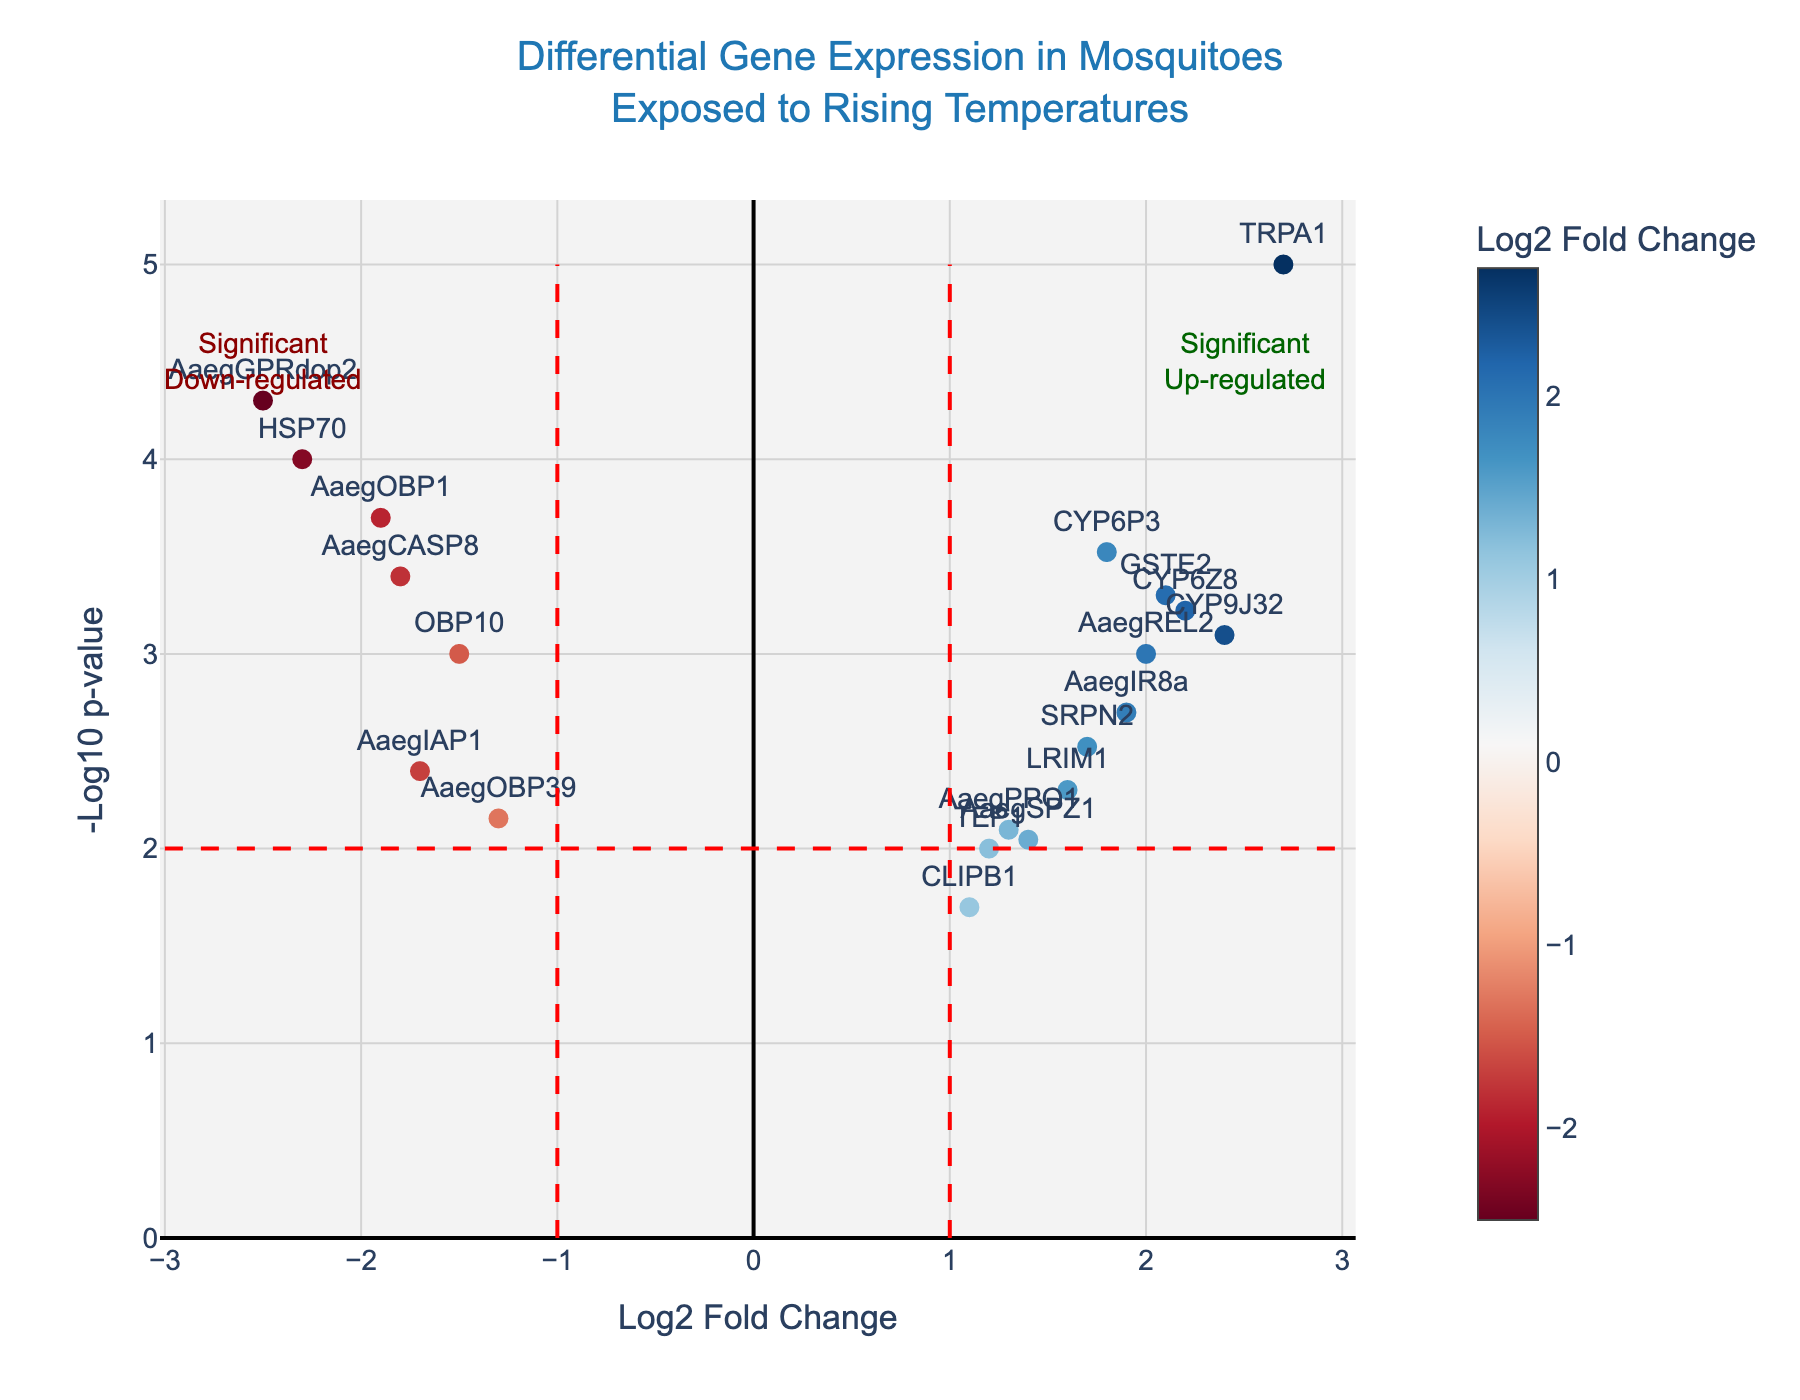Which gene has the greatest log2 fold change? Look at the x-axis values, which represent the log2 fold change, and find the point farthest from zero.
Answer: TRPA1 How many genes are significantly up-regulated? Significant up-regulation is marked by a log2 fold change greater than 1 and a -log10(p-value) greater than 2. Count the points meeting these criteria.
Answer: 7 Which gene has the highest -log10(p-value)? Examine the y-axis values, determining which data point has the highest value.
Answer: TRPA1 What is the color representing down-regulated genes? Identify the color associated with negative log2 fold change values in the colorbar.
Answer: Blue Compare TEP1 and TRPA1: Which is more significantly up-regulated? Find both genes' positions on the plot and compare their log2 fold change and -log10(p-value). TRPA1 has a higher log2 fold change and higher -log10(p-value).
Answer: TRPA1 Are there any genes uniquely highlighted for significant down-regulation? Examine if any points are labeled for significant down-regulation (marked by annotations). Refer to the red zones indicating significance.
Answer: Yes, AaegGPRdop2 (log2 fold change < -1 and -log10(p-value) > 2) How many genes are not differentially expressed? Differential expression is indicated by log2 fold change greater than absolute 1. Count the genes within the range of -1 to 1 on the x-axis.
Answer: 4 Which genes are significantly up-regulated and related to detoxification? Identify genes with log2 fold change > 1 and -log10(p-value) > 2. Recognize those related to detoxification from gene names (e.g., CYP or GST families).
Answer: CYP6P3, CYP6Z8, and GSTE2 What is the range of -log10(p-values) for the genes analyzed? Observe the minimum and maximum values along the y-axis.
Answer: 0 to approximately 5 Compare CYP6P3 and AaegIAP1: Which gene is down-regulated and which is up-regulated? Find these genes on the plot and look at their log2 fold change values. AaegIAP1 has a negative value (down-regulated) while CYP6P3 has a positive value (up-regulated).
Answer: CYP6P3 is up-regulated; AaegIAP1 is down-regulated 